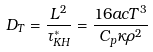<formula> <loc_0><loc_0><loc_500><loc_500>D _ { T } = \frac { L ^ { 2 } } { \tau _ { K H } ^ { * } } = \frac { 1 6 a c T ^ { 3 } } { C _ { p } \kappa \rho ^ { 2 } }</formula> 